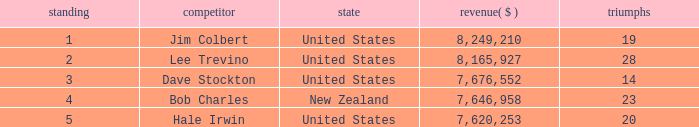How much have players earned with 14 wins ranked below 3? 0.0. 